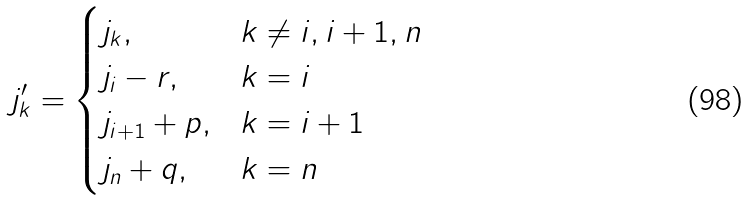<formula> <loc_0><loc_0><loc_500><loc_500>j _ { k } ^ { \prime } = \begin{cases} j _ { k } , & k \neq i , i + 1 , n \\ j _ { i } - r , & k = i \\ j _ { i + 1 } + p , & k = i + 1 \\ j _ { n } + q , & k = n \end{cases}</formula> 